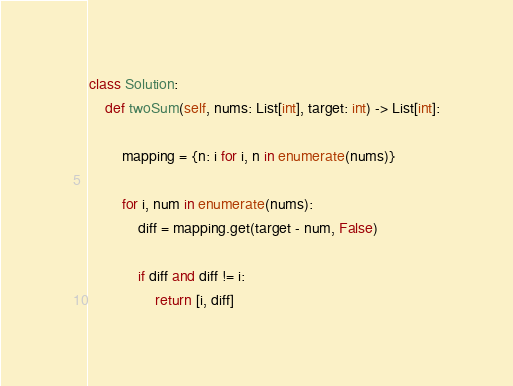Convert code to text. <code><loc_0><loc_0><loc_500><loc_500><_Python_>class Solution:
    def twoSum(self, nums: List[int], target: int) -> List[int]:
                      
        mapping = {n: i for i, n in enumerate(nums)}
        
        for i, num in enumerate(nums):
            diff = mapping.get(target - num, False)
            
            if diff and diff != i:
                return [i, diff]</code> 